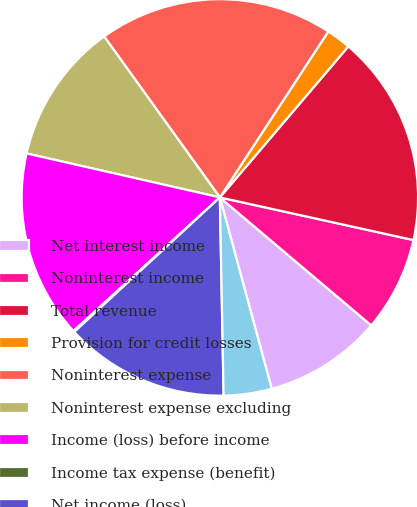Convert chart. <chart><loc_0><loc_0><loc_500><loc_500><pie_chart><fcel>Net interest income<fcel>Noninterest income<fcel>Total revenue<fcel>Provision for credit losses<fcel>Noninterest expense<fcel>Noninterest expense excluding<fcel>Income (loss) before income<fcel>Income tax expense (benefit)<fcel>Net income (loss)<fcel>Net income excluding goodwill<nl><fcel>9.62%<fcel>7.72%<fcel>17.23%<fcel>2.01%<fcel>19.13%<fcel>11.52%<fcel>15.33%<fcel>0.1%<fcel>13.43%<fcel>3.91%<nl></chart> 